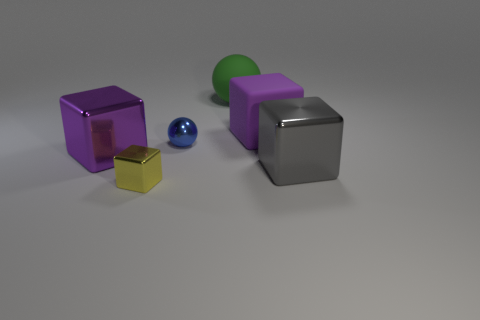Subtract all green cubes. Subtract all cyan spheres. How many cubes are left? 4 Add 1 brown shiny cylinders. How many objects exist? 7 Subtract all balls. How many objects are left? 4 Add 3 large purple metal cylinders. How many large purple metal cylinders exist? 3 Subtract 0 gray balls. How many objects are left? 6 Subtract all purple shiny cylinders. Subtract all large green objects. How many objects are left? 5 Add 6 green balls. How many green balls are left? 7 